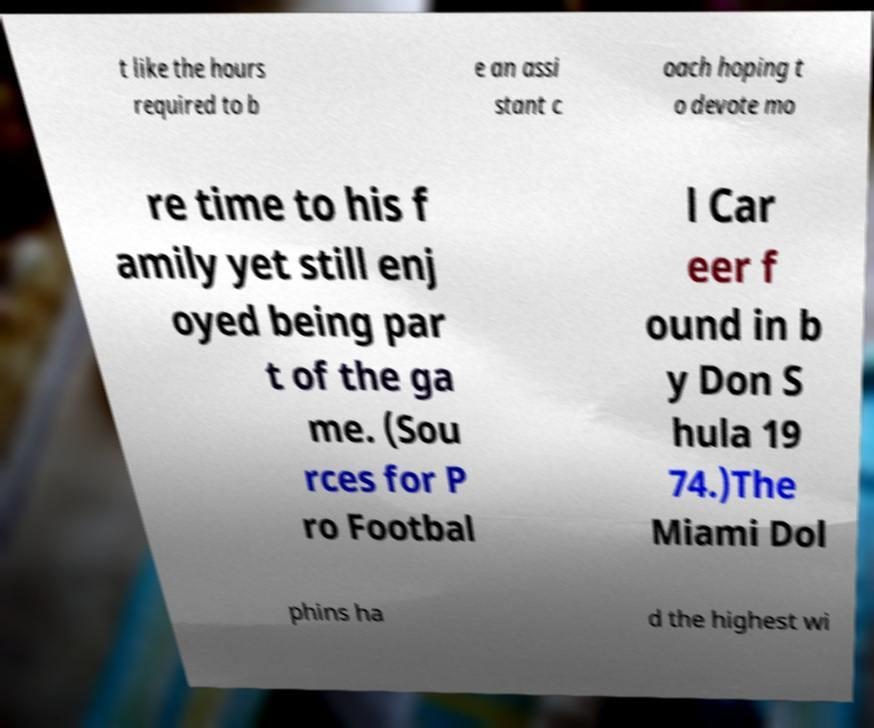For documentation purposes, I need the text within this image transcribed. Could you provide that? t like the hours required to b e an assi stant c oach hoping t o devote mo re time to his f amily yet still enj oyed being par t of the ga me. (Sou rces for P ro Footbal l Car eer f ound in b y Don S hula 19 74.)The Miami Dol phins ha d the highest wi 